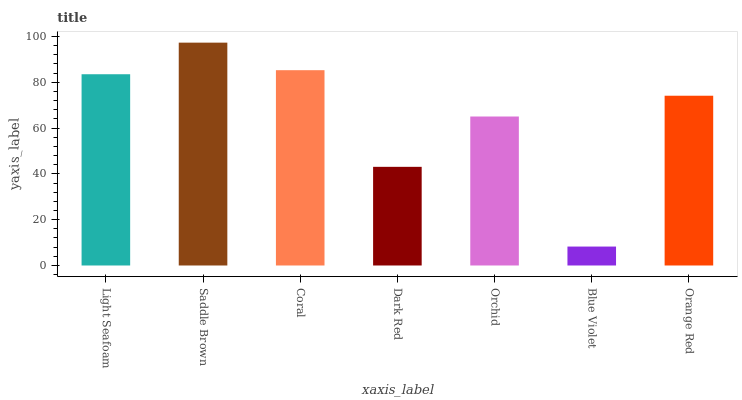Is Blue Violet the minimum?
Answer yes or no. Yes. Is Saddle Brown the maximum?
Answer yes or no. Yes. Is Coral the minimum?
Answer yes or no. No. Is Coral the maximum?
Answer yes or no. No. Is Saddle Brown greater than Coral?
Answer yes or no. Yes. Is Coral less than Saddle Brown?
Answer yes or no. Yes. Is Coral greater than Saddle Brown?
Answer yes or no. No. Is Saddle Brown less than Coral?
Answer yes or no. No. Is Orange Red the high median?
Answer yes or no. Yes. Is Orange Red the low median?
Answer yes or no. Yes. Is Blue Violet the high median?
Answer yes or no. No. Is Coral the low median?
Answer yes or no. No. 